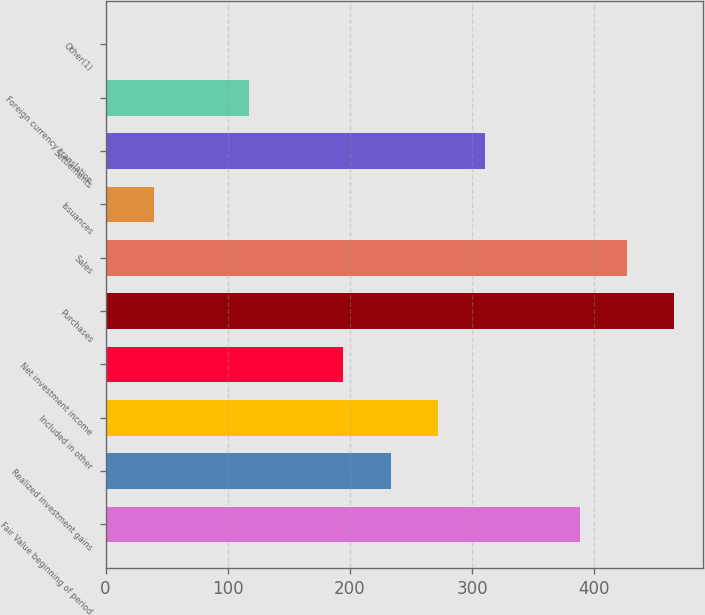<chart> <loc_0><loc_0><loc_500><loc_500><bar_chart><fcel>Fair Value beginning of period<fcel>Realized investment gains<fcel>Included in other<fcel>Net investment income<fcel>Purchases<fcel>Sales<fcel>Issuances<fcel>Settlements<fcel>Foreign currency translation<fcel>Other(1)<nl><fcel>388<fcel>233.28<fcel>271.96<fcel>194.6<fcel>465.36<fcel>426.68<fcel>39.88<fcel>310.64<fcel>117.24<fcel>1.2<nl></chart> 